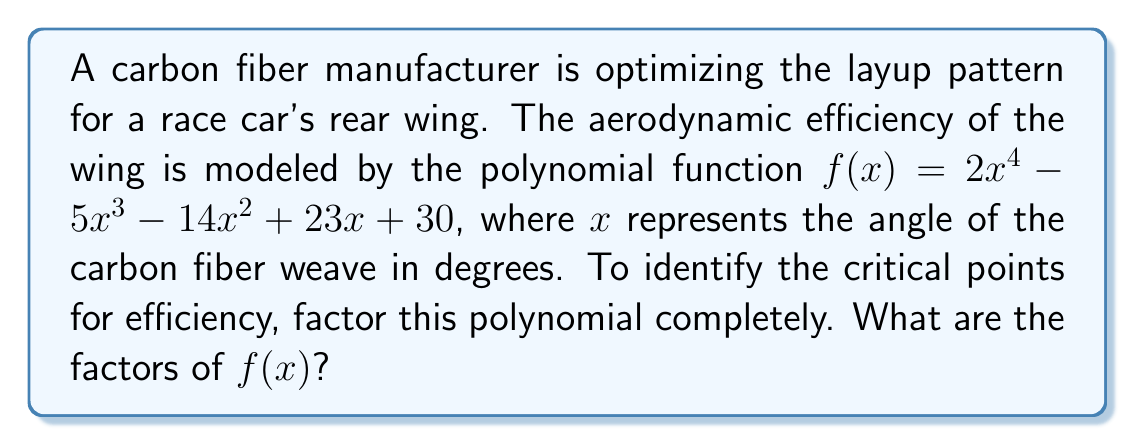Provide a solution to this math problem. Let's approach this step-by-step:

1) First, we check if there are any common factors. In this case, there are none.

2) Next, we can try the rational root theorem. The possible rational roots are the factors of the constant term (30): ±1, ±2, ±3, ±5, ±6, ±10, ±15, ±30.

3) Testing these values, we find that $x = 2$ and $x = -3$ are roots.

4) We can factor out $(x - 2)$ and $(x + 3)$:

   $f(x) = (x - 2)(x + 3)(2x^2 - 3x - 5)$

5) Now we need to factor the quadratic term $2x^2 - 3x - 5$. We can use the quadratic formula:

   $$x = \frac{-b \pm \sqrt{b^2 - 4ac}}{2a}$$

   Where $a = 2$, $b = -3$, and $c = -5$

6) Calculating:

   $$x = \frac{3 \pm \sqrt{9 + 40}}{4} = \frac{3 \pm \sqrt{49}}{4} = \frac{3 \pm 7}{4}$$

7) This gives us two more roots: $x = \frac{5}{2}$ and $x = -\frac{1}{2}$

8) Therefore, the quadratic factor can be written as:

   $2x^2 - 3x - 5 = 2(x - \frac{5}{2})(x + \frac{1}{2})$

9) Putting it all together, we get:

   $f(x) = 2(x - 2)(x + 3)(x - \frac{5}{2})(x + \frac{1}{2})$
Answer: The factors of $f(x)$ are: $2$, $(x - 2)$, $(x + 3)$, $(x - \frac{5}{2})$, and $(x + \frac{1}{2})$. 